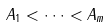<formula> <loc_0><loc_0><loc_500><loc_500>A _ { 1 } < \cdot \cdot \cdot < A _ { m }</formula> 